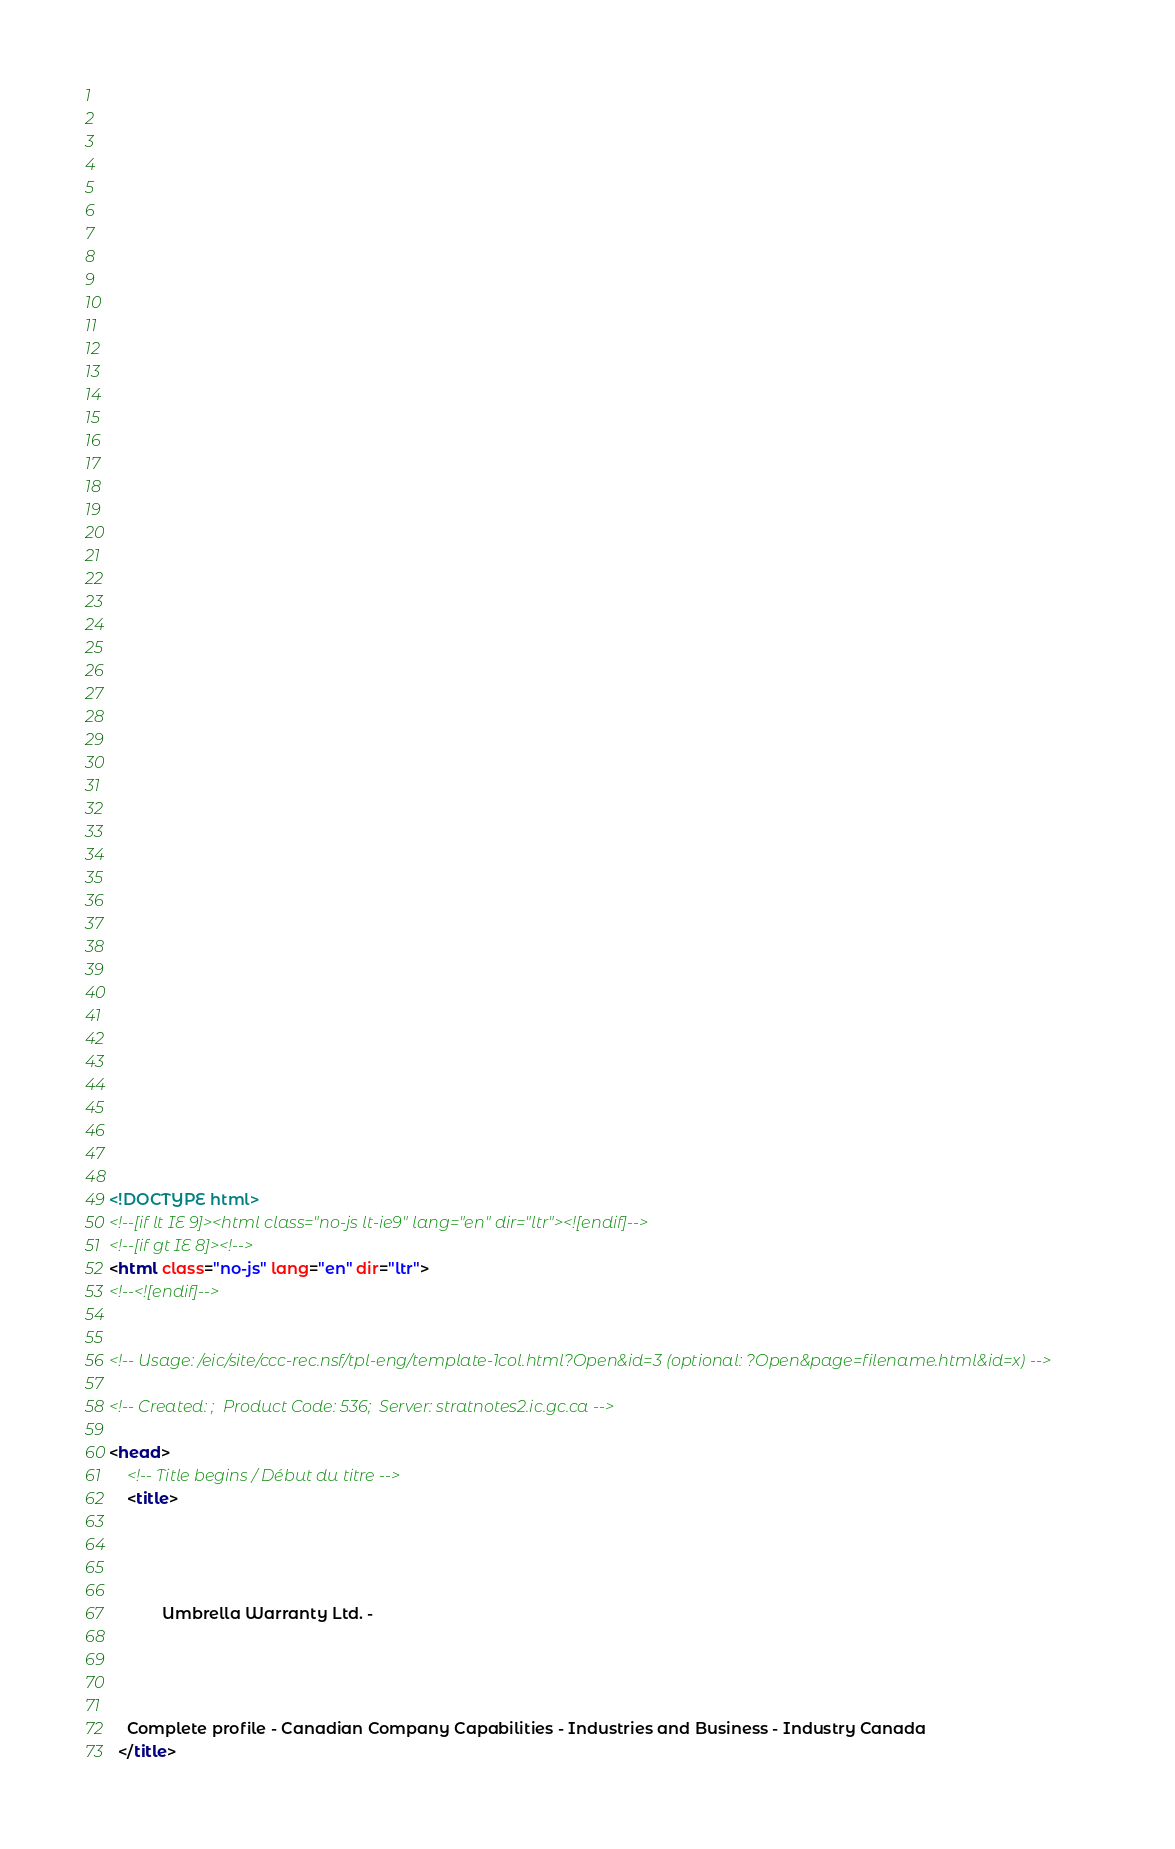Convert code to text. <code><loc_0><loc_0><loc_500><loc_500><_HTML_>


















	






  
  
  
  































	
	
	



<!DOCTYPE html>
<!--[if lt IE 9]><html class="no-js lt-ie9" lang="en" dir="ltr"><![endif]-->
<!--[if gt IE 8]><!-->
<html class="no-js" lang="en" dir="ltr">
<!--<![endif]-->


<!-- Usage: /eic/site/ccc-rec.nsf/tpl-eng/template-1col.html?Open&id=3 (optional: ?Open&page=filename.html&id=x) -->

<!-- Created: ;  Product Code: 536;  Server: stratnotes2.ic.gc.ca -->

<head>
	<!-- Title begins / Début du titre -->
	<title>
    
            
        
          
            Umbrella Warranty Ltd. -
          
        
      
    
    Complete profile - Canadian Company Capabilities - Industries and Business - Industry Canada
  </title></code> 